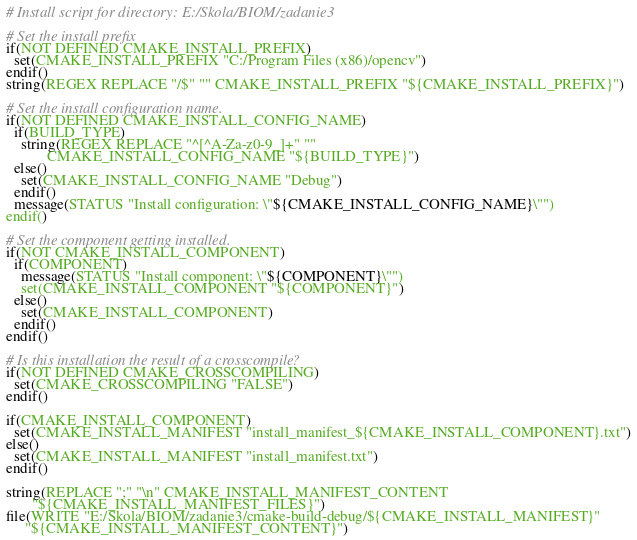Convert code to text. <code><loc_0><loc_0><loc_500><loc_500><_CMake_># Install script for directory: E:/Skola/BIOM/zadanie3

# Set the install prefix
if(NOT DEFINED CMAKE_INSTALL_PREFIX)
  set(CMAKE_INSTALL_PREFIX "C:/Program Files (x86)/opencv")
endif()
string(REGEX REPLACE "/$" "" CMAKE_INSTALL_PREFIX "${CMAKE_INSTALL_PREFIX}")

# Set the install configuration name.
if(NOT DEFINED CMAKE_INSTALL_CONFIG_NAME)
  if(BUILD_TYPE)
    string(REGEX REPLACE "^[^A-Za-z0-9_]+" ""
           CMAKE_INSTALL_CONFIG_NAME "${BUILD_TYPE}")
  else()
    set(CMAKE_INSTALL_CONFIG_NAME "Debug")
  endif()
  message(STATUS "Install configuration: \"${CMAKE_INSTALL_CONFIG_NAME}\"")
endif()

# Set the component getting installed.
if(NOT CMAKE_INSTALL_COMPONENT)
  if(COMPONENT)
    message(STATUS "Install component: \"${COMPONENT}\"")
    set(CMAKE_INSTALL_COMPONENT "${COMPONENT}")
  else()
    set(CMAKE_INSTALL_COMPONENT)
  endif()
endif()

# Is this installation the result of a crosscompile?
if(NOT DEFINED CMAKE_CROSSCOMPILING)
  set(CMAKE_CROSSCOMPILING "FALSE")
endif()

if(CMAKE_INSTALL_COMPONENT)
  set(CMAKE_INSTALL_MANIFEST "install_manifest_${CMAKE_INSTALL_COMPONENT}.txt")
else()
  set(CMAKE_INSTALL_MANIFEST "install_manifest.txt")
endif()

string(REPLACE ";" "\n" CMAKE_INSTALL_MANIFEST_CONTENT
       "${CMAKE_INSTALL_MANIFEST_FILES}")
file(WRITE "E:/Skola/BIOM/zadanie3/cmake-build-debug/${CMAKE_INSTALL_MANIFEST}"
     "${CMAKE_INSTALL_MANIFEST_CONTENT}")
</code> 